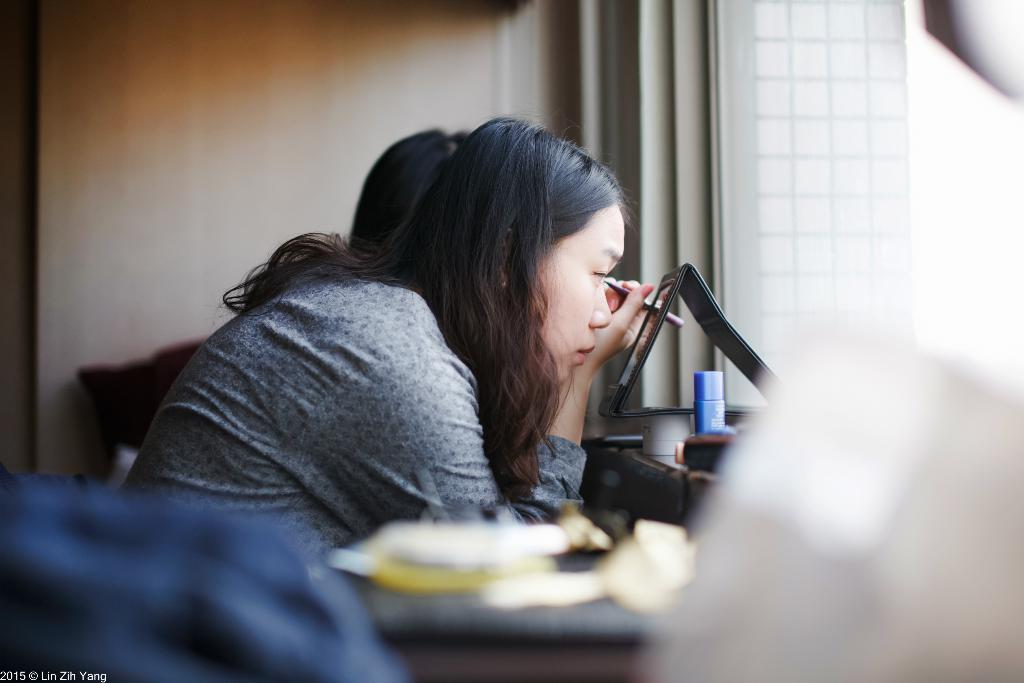Who is the main subject in the image? There is a lady in the center of the image. What is the lady holding in her hand? The lady is holding an eyebrow pencil in her hand. What object might be used for personal grooming in the image? There is a mirror in the image, which can be used for personal grooming. What other item can be seen in the image? There is a bottle in the image. Can you describe the presence of other people in the image? There is at least one other person in the background of the image. What type of honey can be seen dripping from the lady's wing in the image? There is no wing or honey present in the image; the lady is holding an eyebrow pencil and there is no mention of honey or wings in the provided facts. 